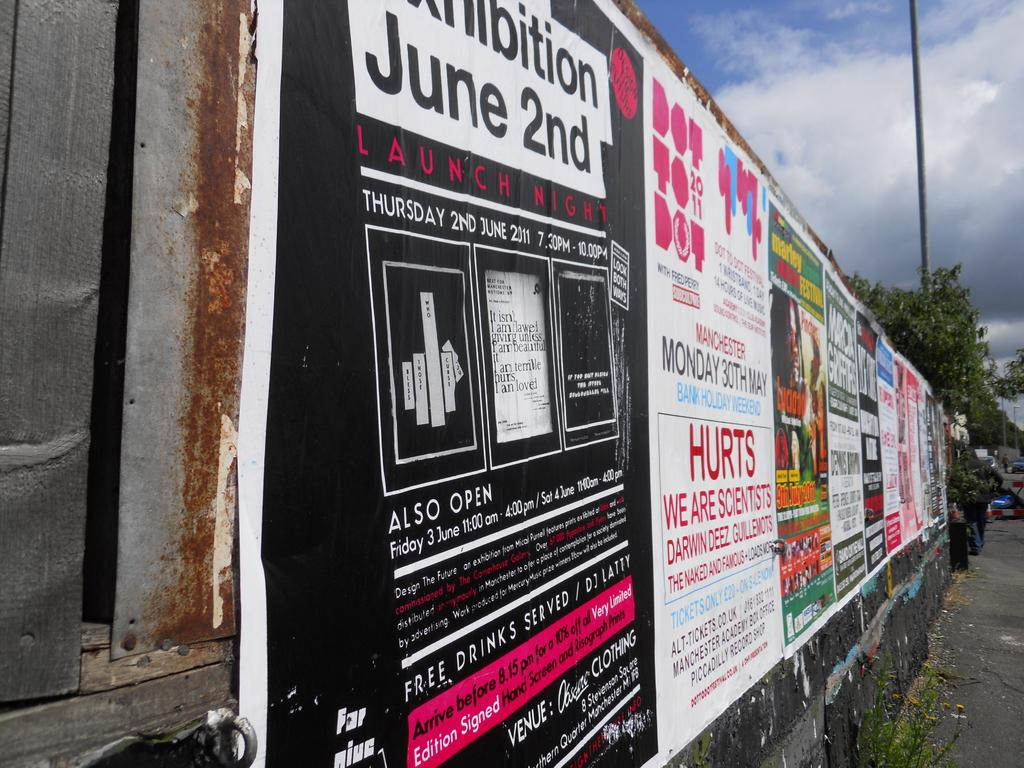What is on the wall in the image? There is a wall with posters on it in the image. What type of vegetation is visible in the image? There are trees in the image. What is the tall, vertical object in the image? There is a pole in the image. What is visible at the top of the image? The sky is visible in the image. What can be seen in the sky in the image? There are clouds in the sky. How does the growth of the trees affect the rifle in the image? There is no growth of trees or rifle present in the image. What type of activity is the person joining in the image? There is no person or activity of joining present in the image. 